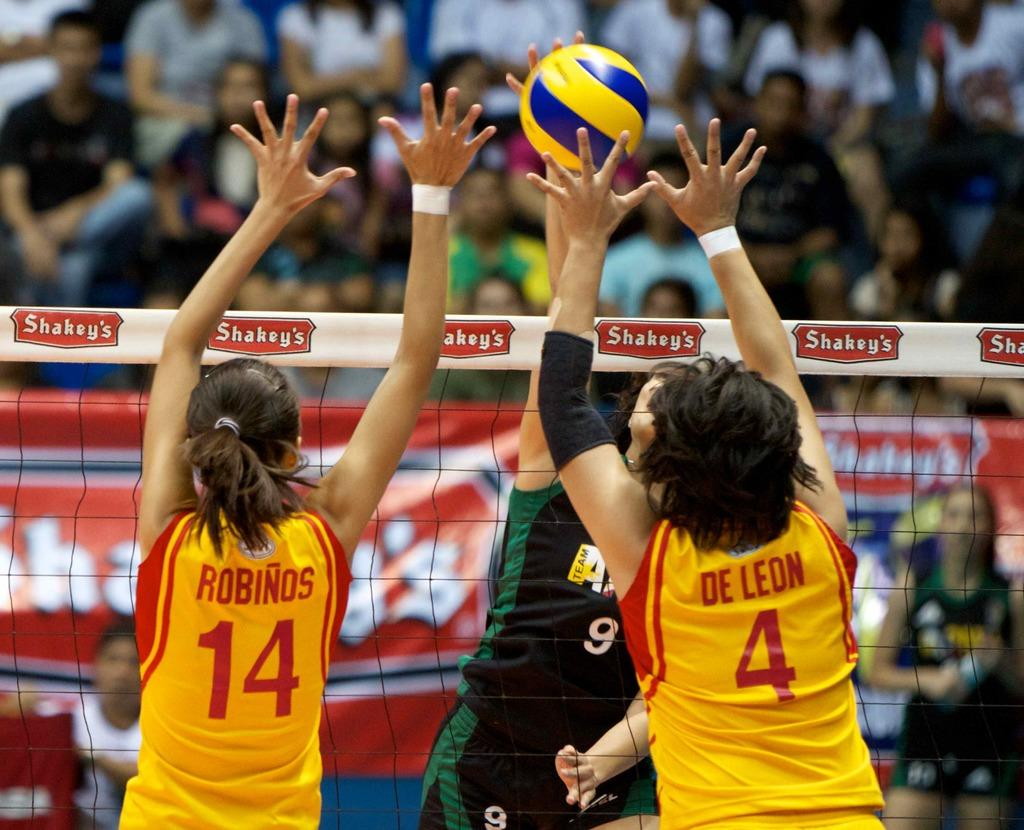What activity are the persons in the image engaged in? The persons in the image are playing volleyball. How is the volleyball game organized? The volleyball players are standing on either side of a net. What can be observed in the background of the image? There are many people sitting in the background, and they are looking at the volleyball game. What type of loaf is being used as a volleyball in the image? There is no loaf present in the image; the volleyball players are using a volleyball. Where is the stage located in the image? There is no stage present in the image; it is a volleyball game taking place outdoors. 